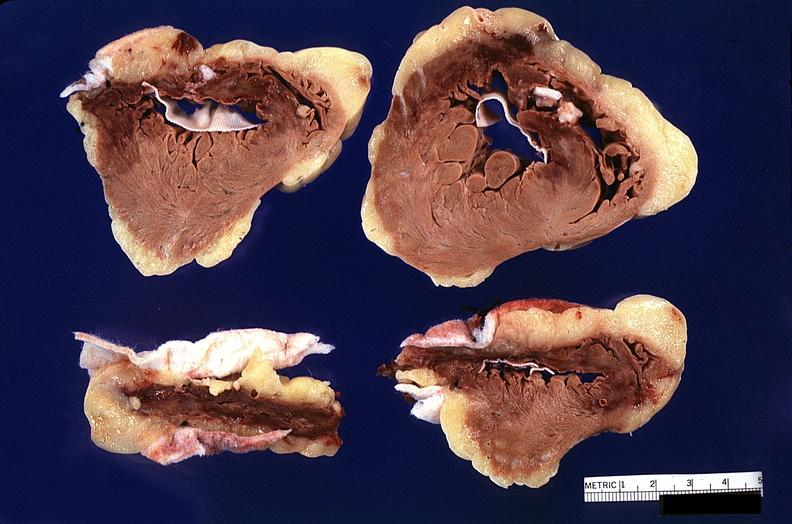s lymphangiomatosis generalized present?
Answer the question using a single word or phrase. No 